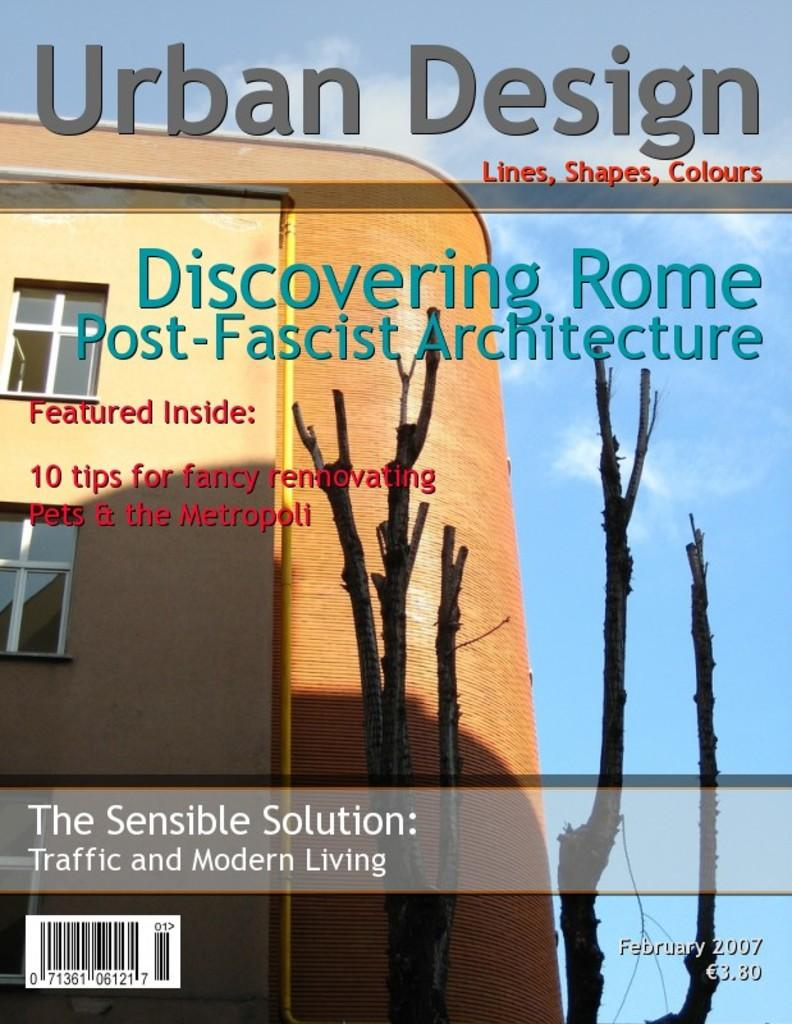What is the main subject of the poster? The main subject of the poster is a building. Are there any other elements depicted on the poster besides the building? Yes, there is a tree depicted on the poster. What can be seen in the background of the poster? The sky is visible on the poster. Is there any text present on the poster? Yes, there is text written on the poster. What type of song can be heard playing in the background of the poster? There is no song or audio present in the poster; it is a visual representation of a building, tree, and text. 